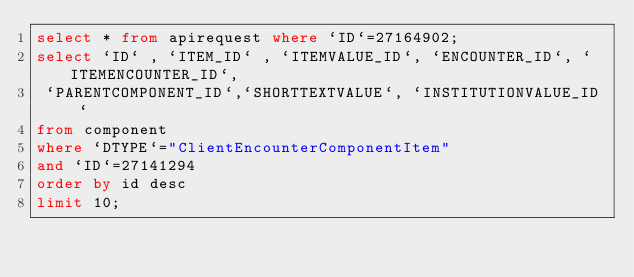Convert code to text. <code><loc_0><loc_0><loc_500><loc_500><_SQL_>select * from apirequest where `ID`=27164902;
select `ID` , `ITEM_ID` , `ITEMVALUE_ID`, `ENCOUNTER_ID`, `ITEMENCOUNTER_ID`,
 `PARENTCOMPONENT_ID`,`SHORTTEXTVALUE`, `INSTITUTIONVALUE_ID`
from component
where `DTYPE`="ClientEncounterComponentItem"
and `ID`=27141294
order by id desc
limit 10;</code> 